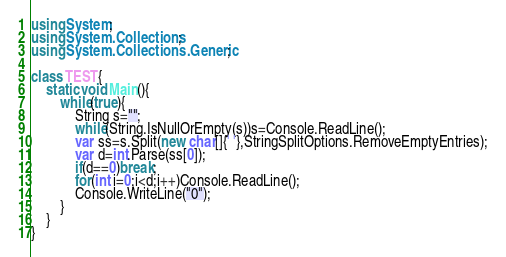Convert code to text. <code><loc_0><loc_0><loc_500><loc_500><_C#_>using System;
using System.Collections;
using System.Collections.Generic;
 
class TEST{
	static void Main(){
		while(true){
			String s="";
			while(String.IsNullOrEmpty(s))s=Console.ReadLine();
			var ss=s.Split(new char[]{' '},StringSplitOptions.RemoveEmptyEntries);
			var d=int.Parse(ss[0]);
			if(d==0)break;
			for(int i=0;i<d;i++)Console.ReadLine();
			Console.WriteLine("0");
		}
	}
}</code> 